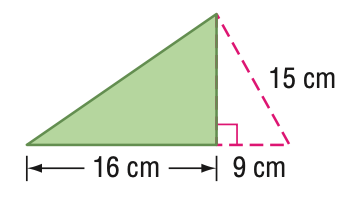Answer the mathemtical geometry problem and directly provide the correct option letter.
Question: Find the area of the triangle. Round to the nearest tenth if necessary.
Choices: A: 96 B: 135 C: 192 D: 240 A 